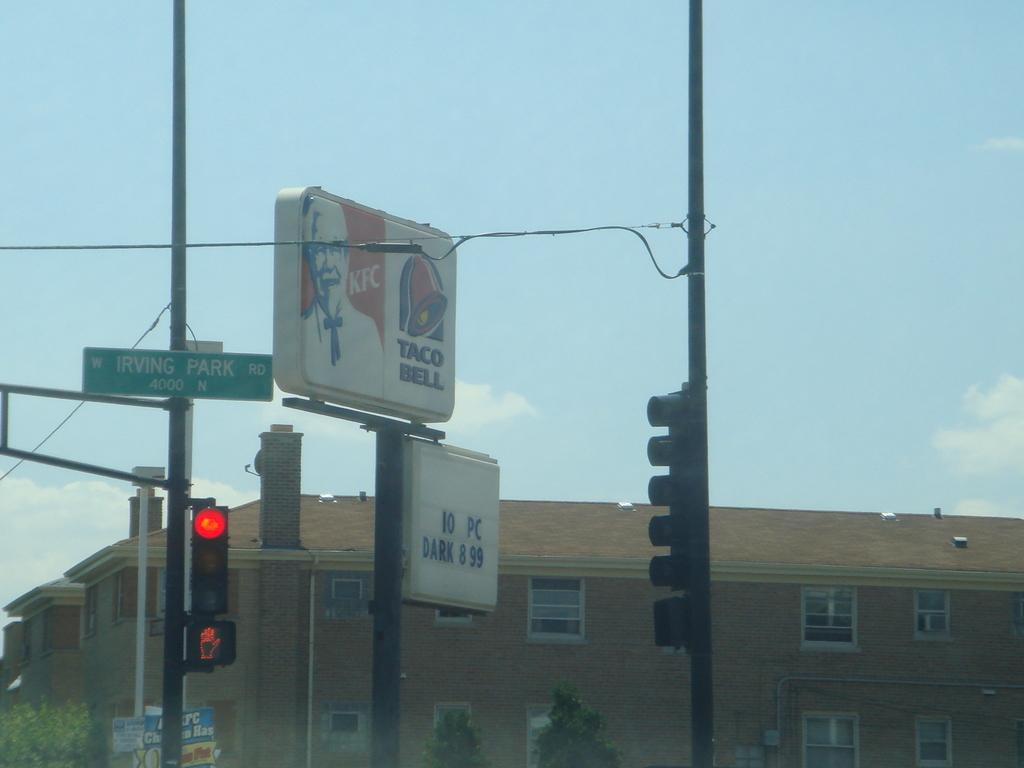<image>
Summarize the visual content of the image. Two separate businesses, Kentucky Fried Chicken and Taco Bell, share the same sign. 